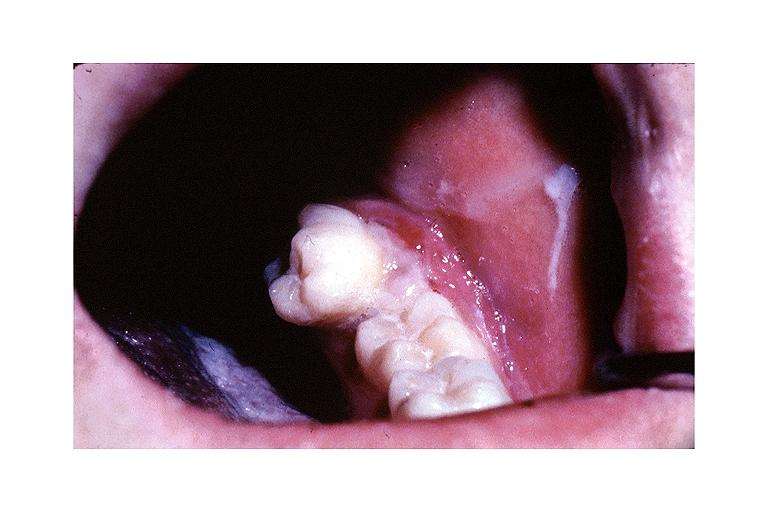does this image show metastatic adenocarcinoma?
Answer the question using a single word or phrase. Yes 